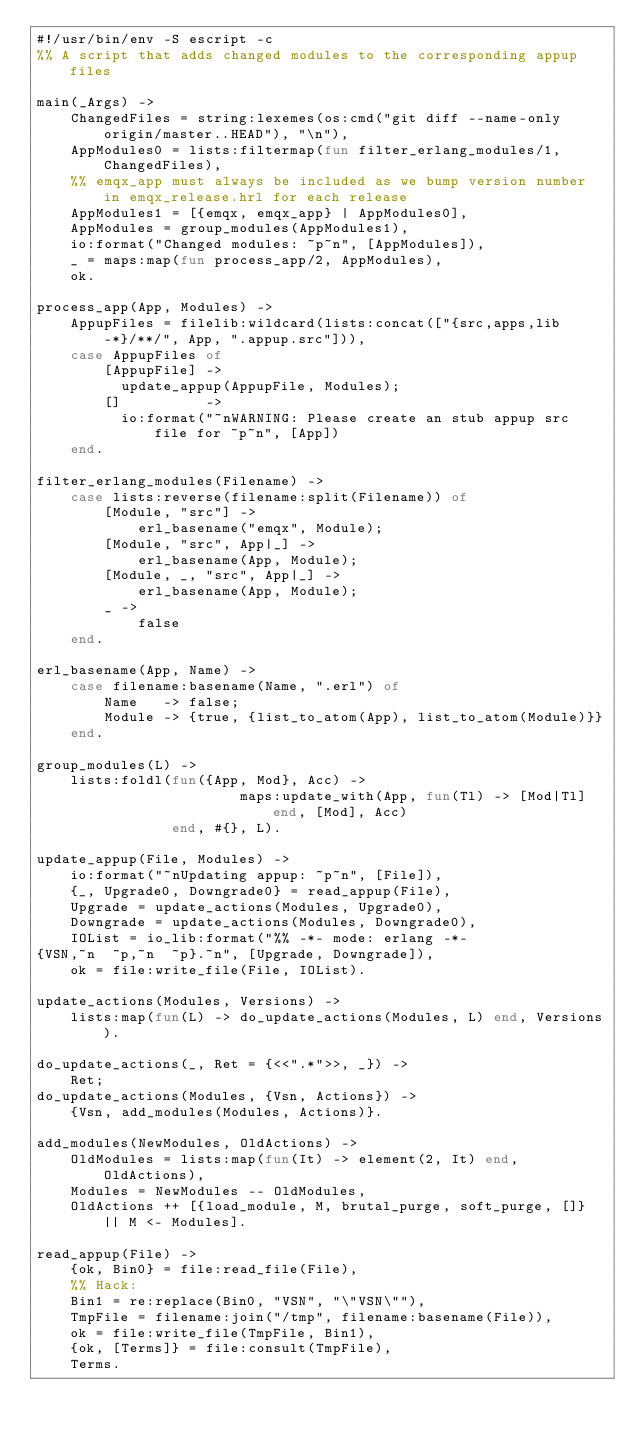Convert code to text. <code><loc_0><loc_0><loc_500><loc_500><_Erlang_>#!/usr/bin/env -S escript -c
%% A script that adds changed modules to the corresponding appup files

main(_Args) ->
    ChangedFiles = string:lexemes(os:cmd("git diff --name-only origin/master..HEAD"), "\n"),
    AppModules0 = lists:filtermap(fun filter_erlang_modules/1, ChangedFiles),
    %% emqx_app must always be included as we bump version number in emqx_release.hrl for each release
    AppModules1 = [{emqx, emqx_app} | AppModules0],
    AppModules = group_modules(AppModules1),
    io:format("Changed modules: ~p~n", [AppModules]),
    _ = maps:map(fun process_app/2, AppModules),
    ok.

process_app(App, Modules) ->
    AppupFiles = filelib:wildcard(lists:concat(["{src,apps,lib-*}/**/", App, ".appup.src"])),
    case AppupFiles of
        [AppupFile] ->
          update_appup(AppupFile, Modules);
        []          ->
          io:format("~nWARNING: Please create an stub appup src file for ~p~n", [App])
    end.

filter_erlang_modules(Filename) ->
    case lists:reverse(filename:split(Filename)) of
        [Module, "src"] ->
            erl_basename("emqx", Module);
        [Module, "src", App|_] ->
            erl_basename(App, Module);
        [Module, _, "src", App|_] ->
            erl_basename(App, Module);
        _ ->
            false
    end.

erl_basename(App, Name) ->
    case filename:basename(Name, ".erl") of
        Name   -> false;
        Module -> {true, {list_to_atom(App), list_to_atom(Module)}}
    end.

group_modules(L) ->
    lists:foldl(fun({App, Mod}, Acc) ->
                        maps:update_with(App, fun(Tl) -> [Mod|Tl] end, [Mod], Acc)
                end, #{}, L).

update_appup(File, Modules) ->
    io:format("~nUpdating appup: ~p~n", [File]),
    {_, Upgrade0, Downgrade0} = read_appup(File),
    Upgrade = update_actions(Modules, Upgrade0),
    Downgrade = update_actions(Modules, Downgrade0),
    IOList = io_lib:format("%% -*- mode: erlang -*-
{VSN,~n  ~p,~n  ~p}.~n", [Upgrade, Downgrade]),
    ok = file:write_file(File, IOList).

update_actions(Modules, Versions) ->
    lists:map(fun(L) -> do_update_actions(Modules, L) end, Versions).

do_update_actions(_, Ret = {<<".*">>, _}) ->
    Ret;
do_update_actions(Modules, {Vsn, Actions}) ->
    {Vsn, add_modules(Modules, Actions)}.

add_modules(NewModules, OldActions) ->
    OldModules = lists:map(fun(It) -> element(2, It) end, OldActions),
    Modules = NewModules -- OldModules,
    OldActions ++ [{load_module, M, brutal_purge, soft_purge, []} || M <- Modules].

read_appup(File) ->
    {ok, Bin0} = file:read_file(File),
    %% Hack:
    Bin1 = re:replace(Bin0, "VSN", "\"VSN\""),
    TmpFile = filename:join("/tmp", filename:basename(File)),
    ok = file:write_file(TmpFile, Bin1),
    {ok, [Terms]} = file:consult(TmpFile),
    Terms.
</code> 